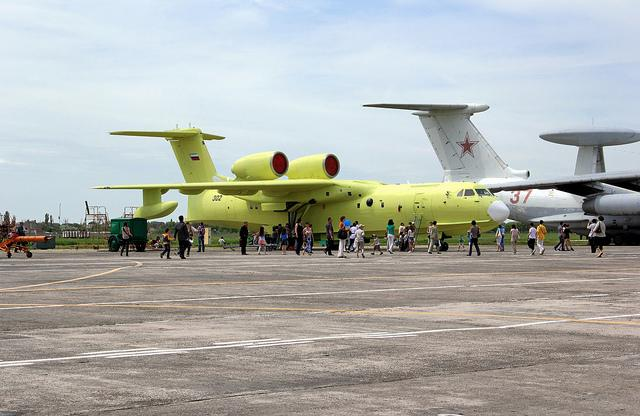What item is painted in an unconventional color? Please explain your reasoning. nearest plane. Most military aircraft are painted gray but this one is yellow. 